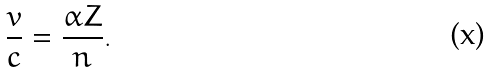<formula> <loc_0><loc_0><loc_500><loc_500>\frac { v } { c } = \frac { \alpha Z } { n } .</formula> 